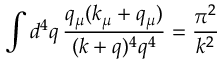<formula> <loc_0><loc_0><loc_500><loc_500>\int d ^ { 4 } q \, \frac { q _ { \mu } ( k _ { \mu } + q _ { \mu } ) } { ( k + q ) ^ { 4 } q ^ { 4 } } = \frac { \pi ^ { 2 } } { k ^ { 2 } }</formula> 